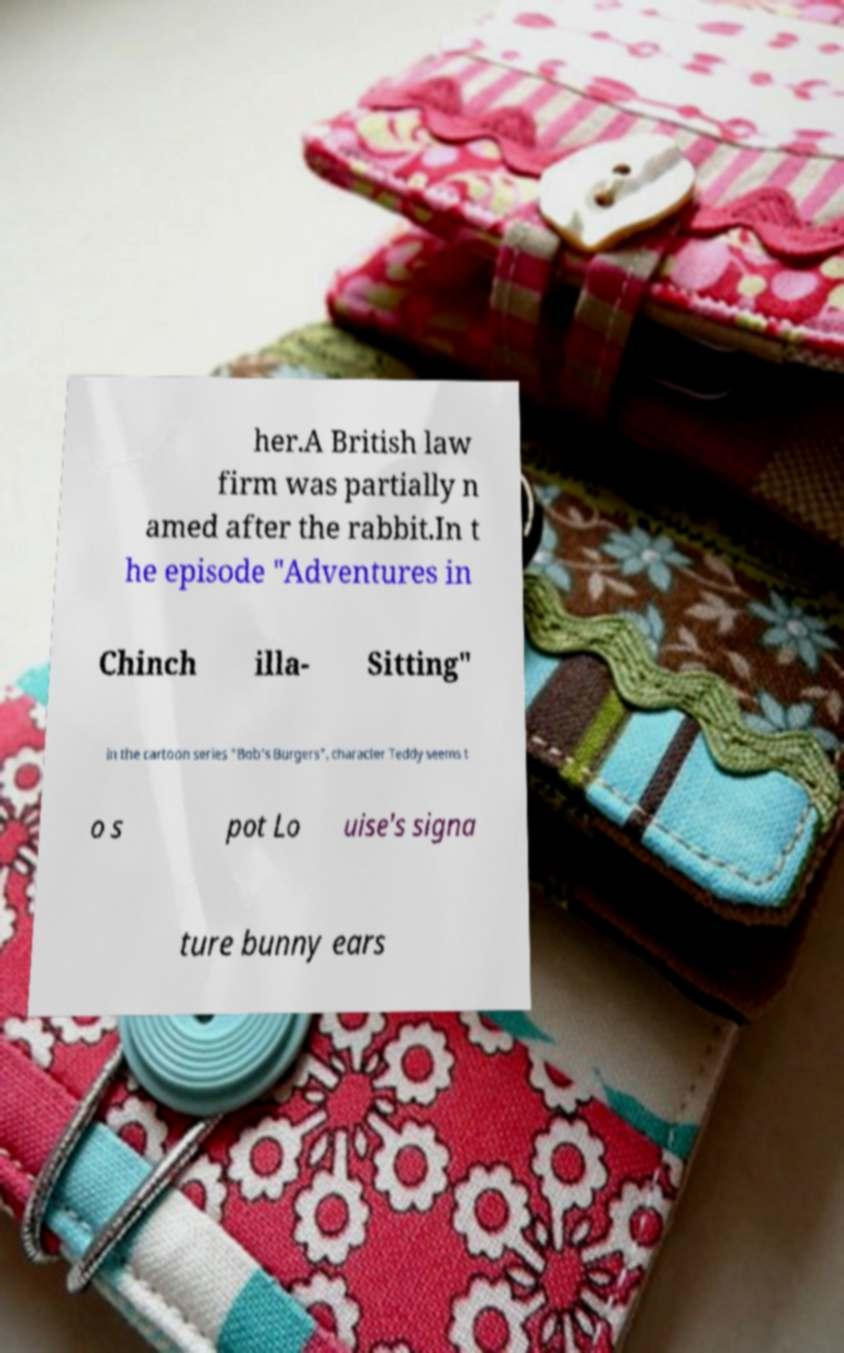I need the written content from this picture converted into text. Can you do that? her.A British law firm was partially n amed after the rabbit.In t he episode "Adventures in Chinch illa- Sitting" in the cartoon series "Bob's Burgers", character Teddy seems t o s pot Lo uise's signa ture bunny ears 